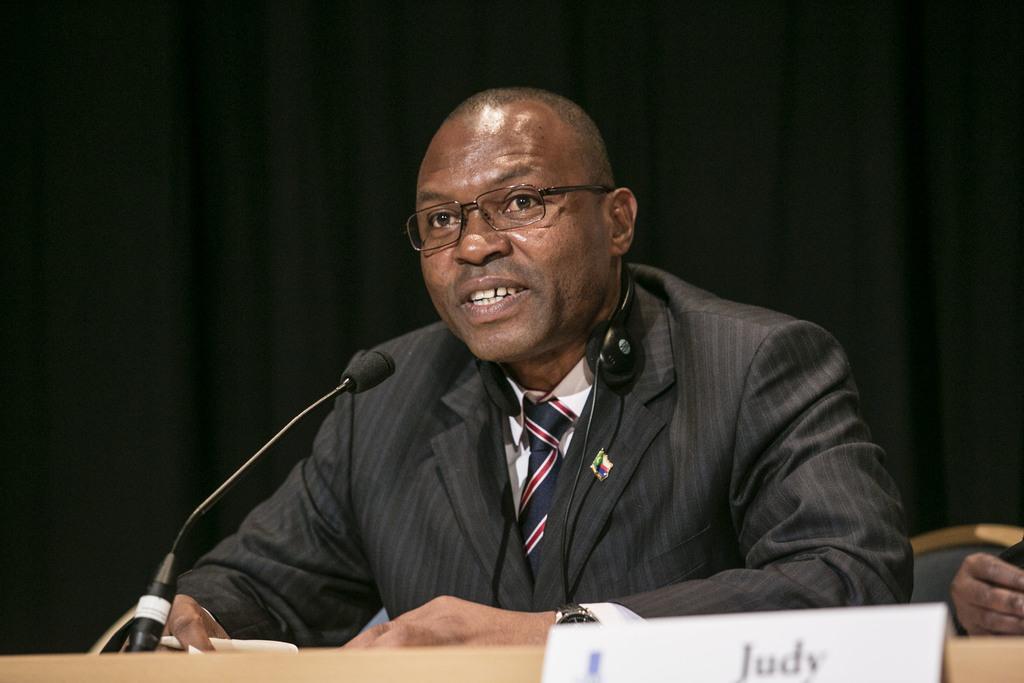Can you describe this image briefly? Here in this picture we can see a person sitting on a chair with table in front of him, speaking something in the microphone present in front of him and he is wearing a suit and we can see headset on his neck and we can see spectacles on him and we can see name board present on the table over there. 